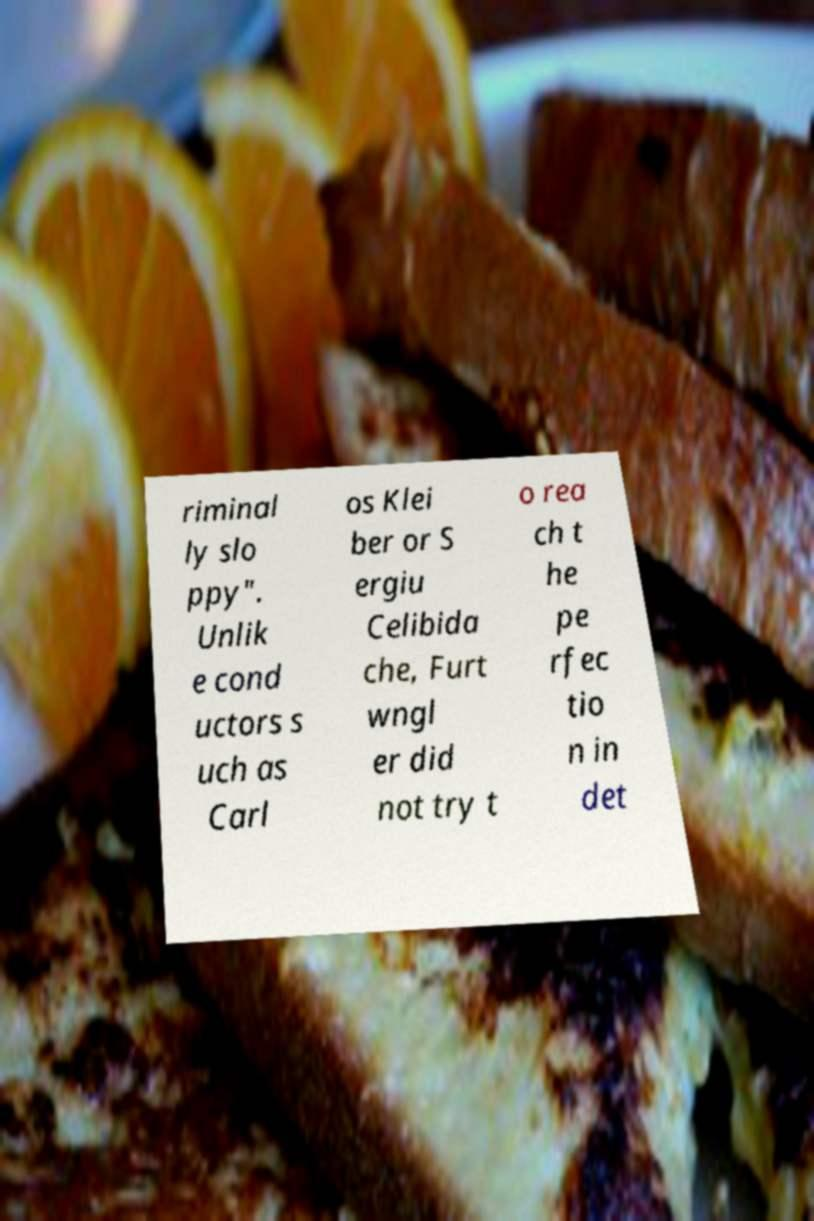There's text embedded in this image that I need extracted. Can you transcribe it verbatim? riminal ly slo ppy". Unlik e cond uctors s uch as Carl os Klei ber or S ergiu Celibida che, Furt wngl er did not try t o rea ch t he pe rfec tio n in det 